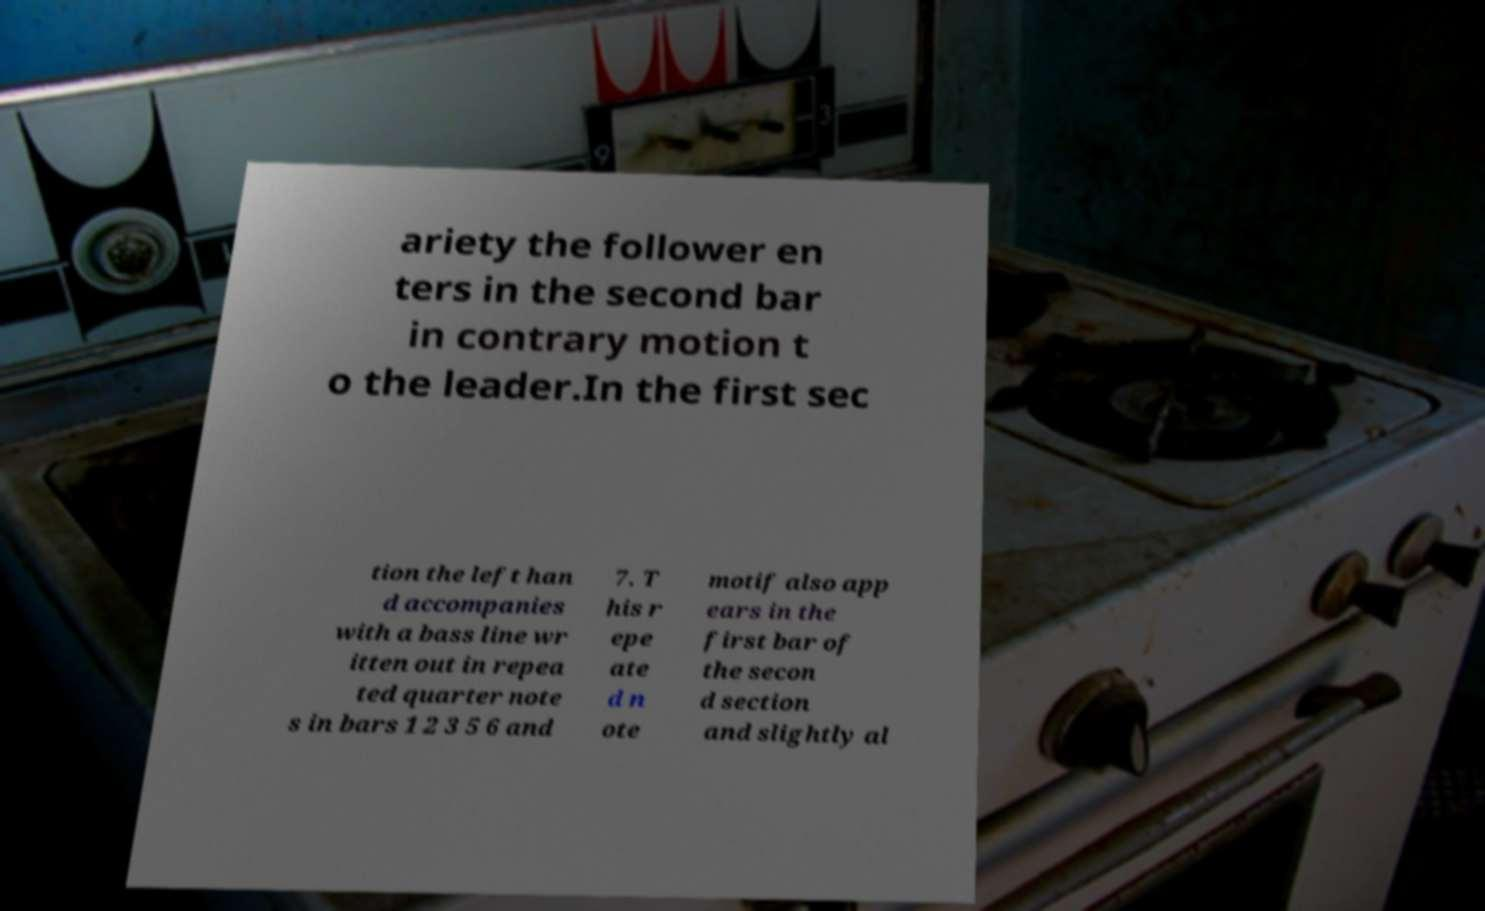There's text embedded in this image that I need extracted. Can you transcribe it verbatim? ariety the follower en ters in the second bar in contrary motion t o the leader.In the first sec tion the left han d accompanies with a bass line wr itten out in repea ted quarter note s in bars 1 2 3 5 6 and 7. T his r epe ate d n ote motif also app ears in the first bar of the secon d section and slightly al 